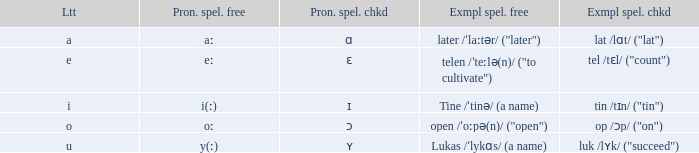Parse the table in full. {'header': ['Ltt', 'Pron. spel. free', 'Pron. spel. chkd', 'Exmpl spel. free', 'Exmpl spel. chkd'], 'rows': [['a', 'aː', 'ɑ', 'later /ˈlaːtər/ ("later")', 'lat /lɑt/ ("lat")'], ['e', 'eː', 'ɛ', 'telen /ˈteːlə(n)/ ("to cultivate")', 'tel /tɛl/ ("count")'], ['i', 'i(ː)', 'ɪ', 'Tine /ˈtinə/ (a name)', 'tin /tɪn/ ("tin")'], ['o', 'oː', 'ɔ', 'open /ˈoːpə(n)/ ("open")', 'op /ɔp/ ("on")'], ['u', 'y(ː)', 'ʏ', 'Lukas /ˈlykɑs/ (a name)', 'luk /lʏk/ ("succeed")']]} When pronunciation spelled checked is given as "ɛ", what is the meaning of pronunciation spelled free? Eː. 